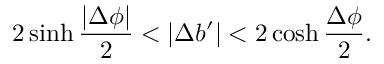Convert formula to latex. <formula><loc_0><loc_0><loc_500><loc_500>2 \sinh { \frac { | \Delta \phi | } { 2 } } < | \Delta b ^ { \prime } | < 2 \cosh { \frac { \Delta \phi } { 2 } } .</formula> 